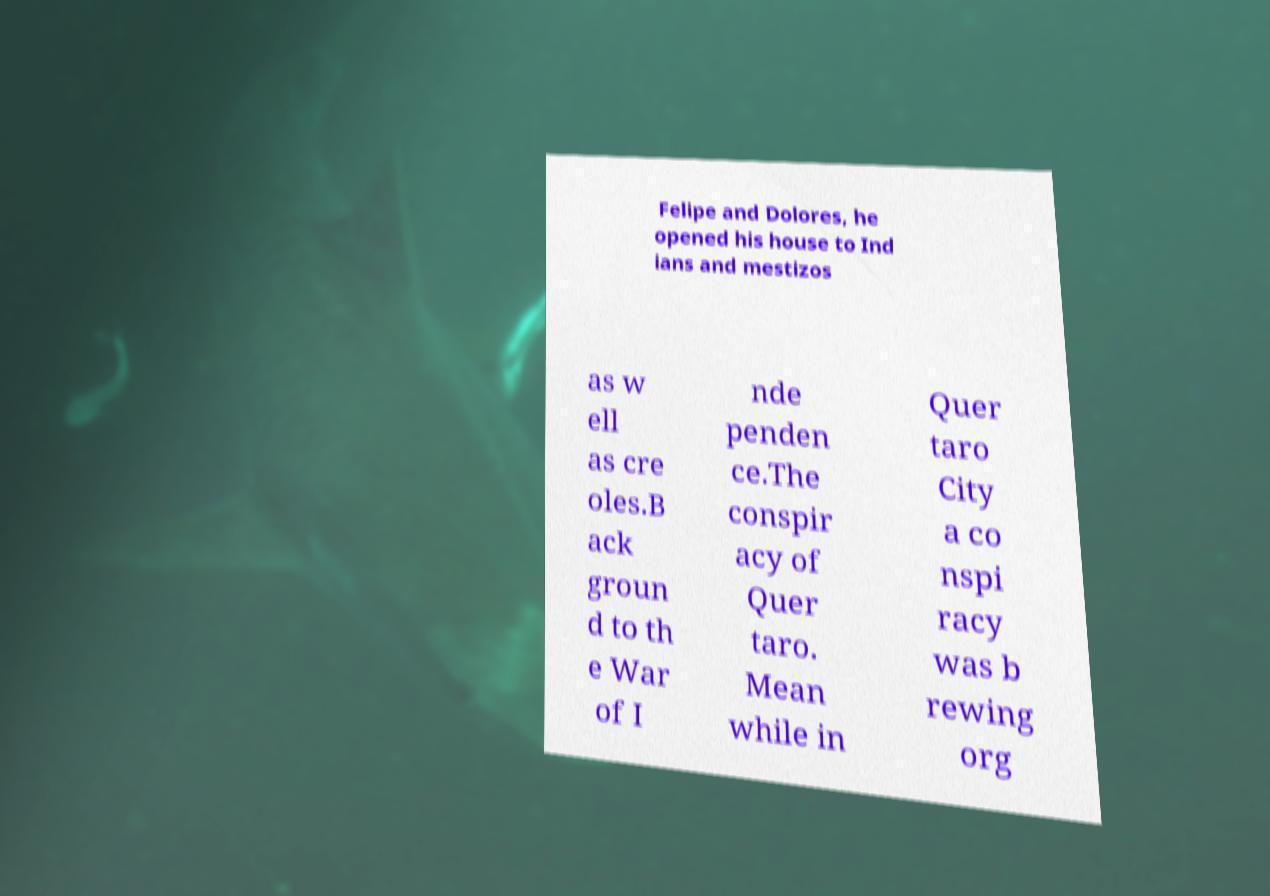Please identify and transcribe the text found in this image. Felipe and Dolores, he opened his house to Ind ians and mestizos as w ell as cre oles.B ack groun d to th e War of I nde penden ce.The conspir acy of Quer taro. Mean while in Quer taro City a co nspi racy was b rewing org 